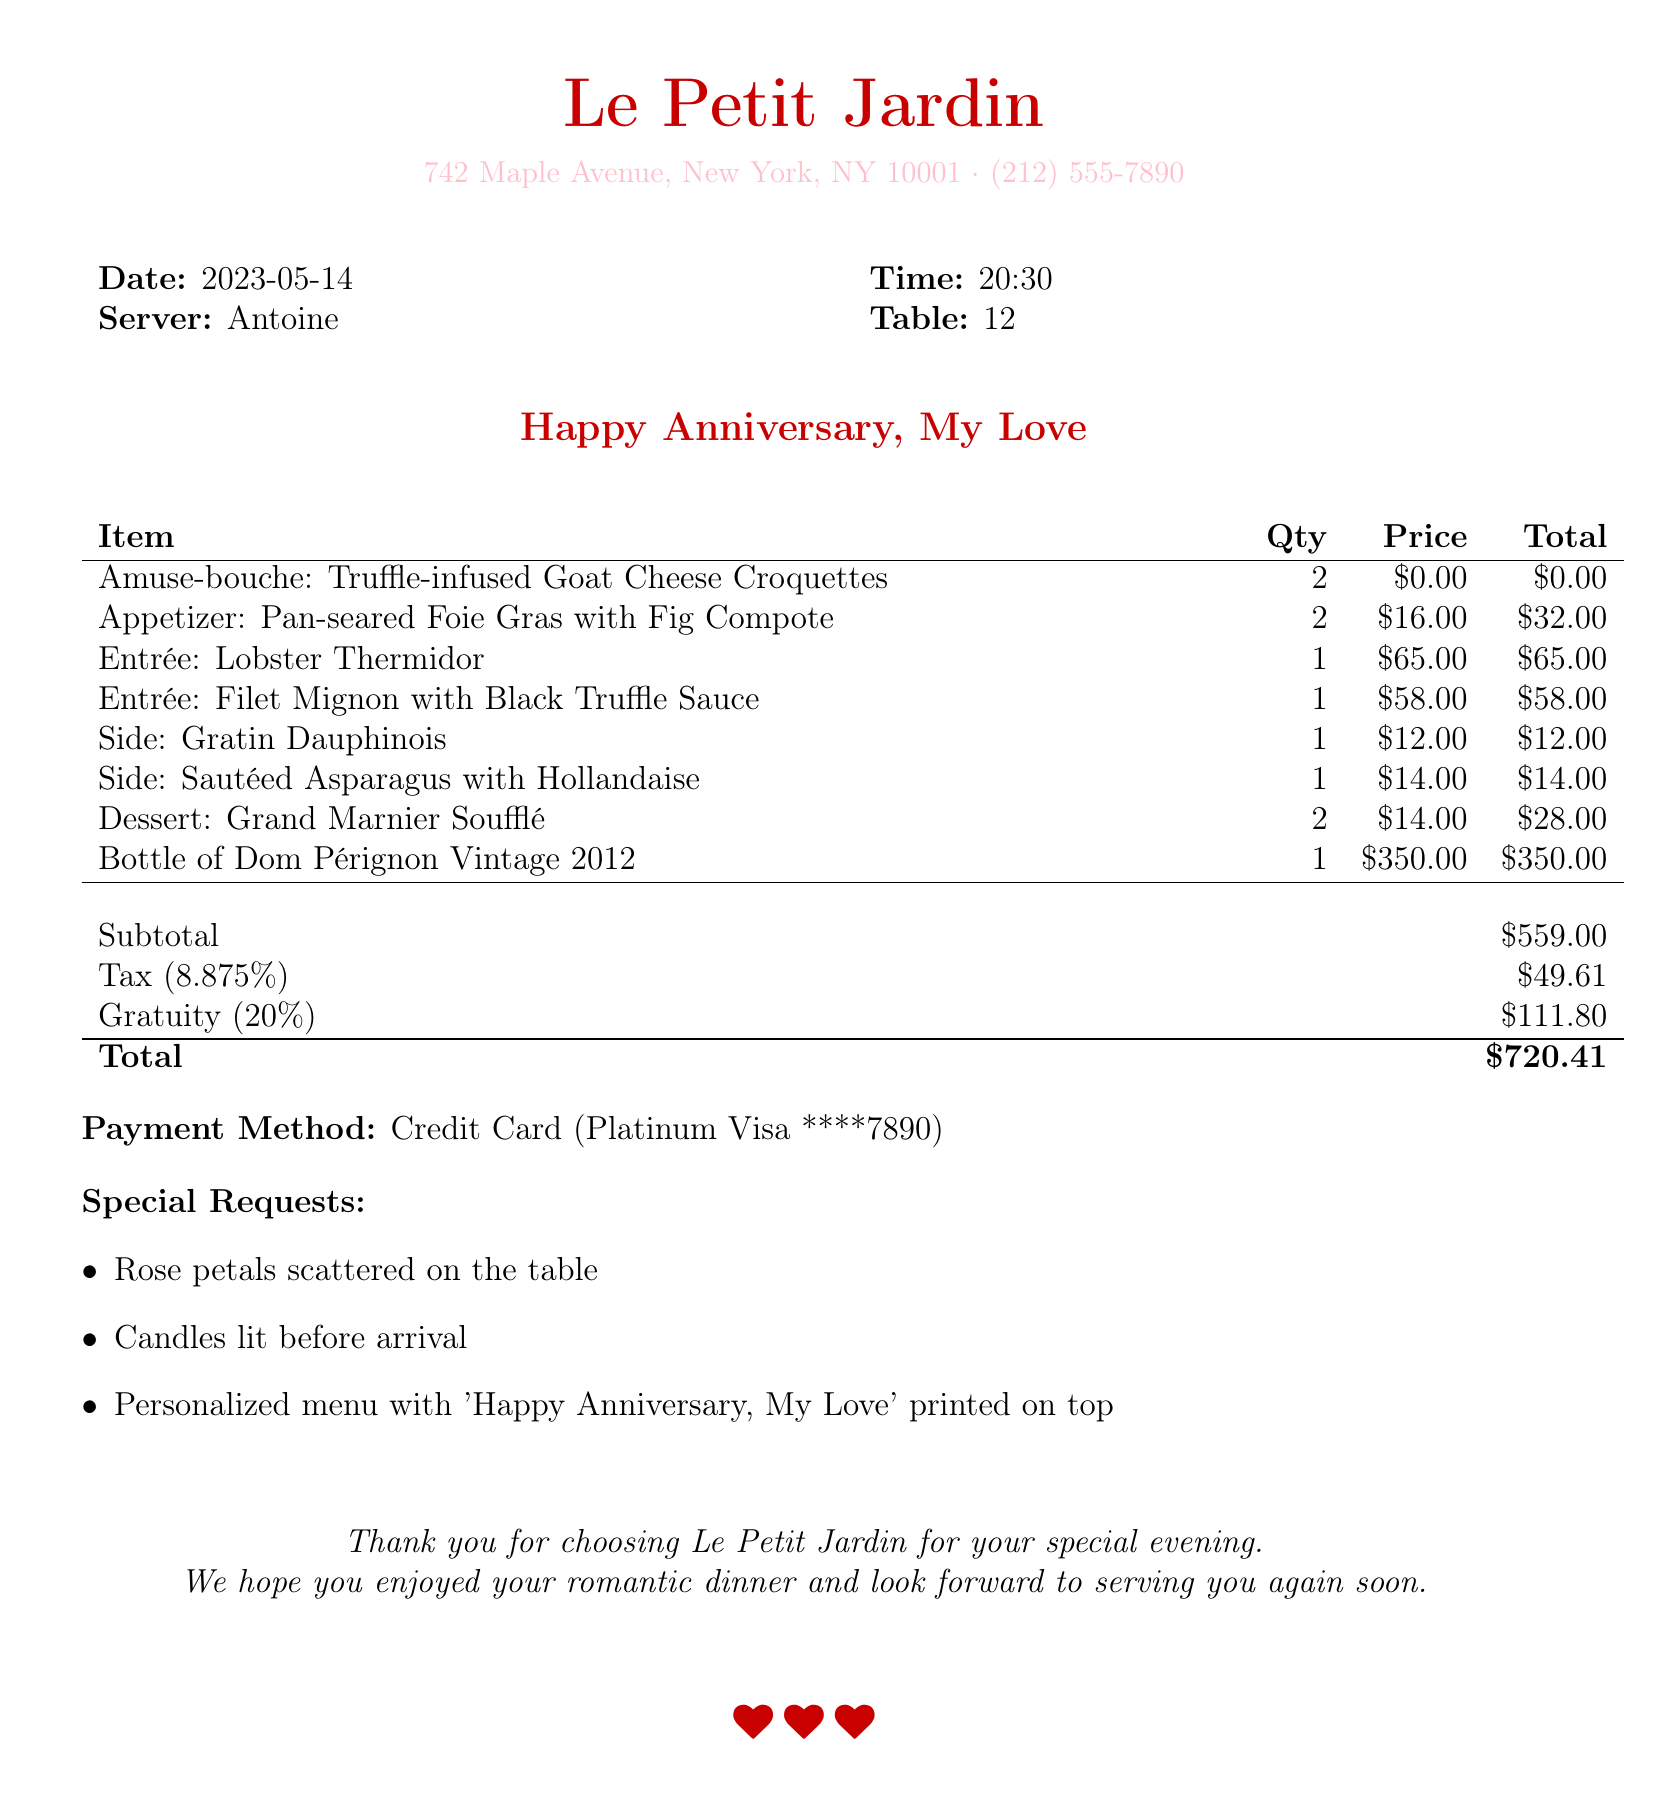What is the name of the restaurant? The name of the restaurant is provided at the top of the receipt.
Answer: Le Petit Jardin What is the date of the dinner? The date is stated clearly in the receipt under the date section.
Answer: 2023-05-14 Who was the server for the evening? The server's name is mentioned in the document in the server section.
Answer: Antoine What was the total amount billed for the dinner? The total amount is the final figure presented at the bottom of the receipt.
Answer: $720.41 How many appetizers were ordered? The number of appetizers is mentioned in the itemized list of the receipt.
Answer: 2 What special request involved decorations? The special requests are listed and one mentions decoration-related details.
Answer: Rose petals scattered on the table What was included with the entrance for the meal? The receipt lists the main dishes ordered, providing insights on what was served.
Answer: Lobster Thermidor and Filet Mignon with Black Truffle Sauce How many desserts were ordered? The quantity of desserts can be found in the itemized list of the receipt.
Answer: 2 What type of payment was used? The payment method is specified at the bottom of the document.
Answer: Credit Card 